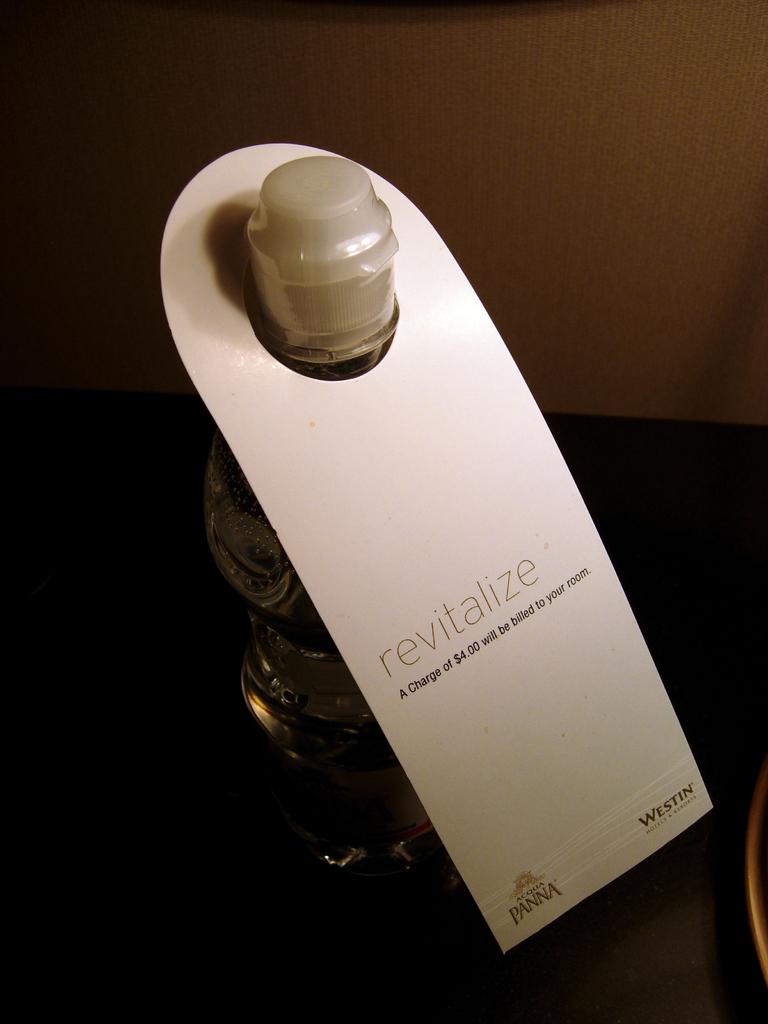What hotel is this from?
Your response must be concise. Westin. 